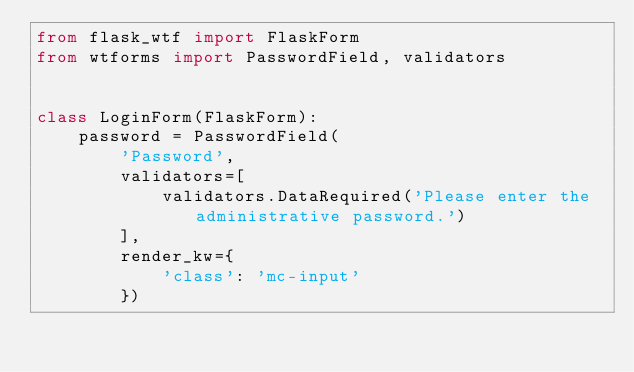Convert code to text. <code><loc_0><loc_0><loc_500><loc_500><_Python_>from flask_wtf import FlaskForm
from wtforms import PasswordField, validators


class LoginForm(FlaskForm):
    password = PasswordField(
        'Password',
        validators=[
            validators.DataRequired('Please enter the administrative password.')
        ],
        render_kw={
            'class': 'mc-input'
        })
</code> 